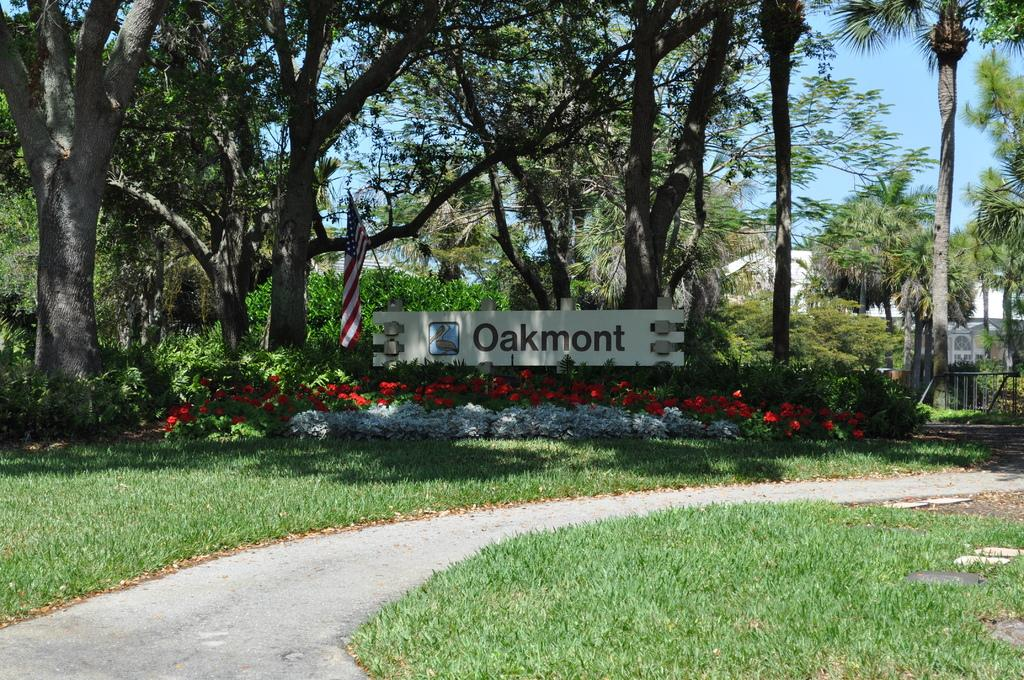What type of surface can be seen in the image? There is ground visible in the image. What type of pathway is present in the image? There is a road in the image. What type of vegetation is present in the image? There is grass, plants, and trees in the image. What type of signage is present in the image? There are posters and a flag in the image. What type of objects are on the ground in the image? There are objects on the ground in the image. What type of structure is present in the image? There is a wall in the image. What type of sky is visible in the image? The sky is visible in the image. What type of bell can be heard ringing in the image? There is no bell present in the image, and therefore no sound can be heard. What type of shade is covering the plants in the image? There is no shade covering the plants in the image; they are exposed to the sky. What type of knot is tied around the flagpole in the image? There is no knot tied around the flagpole in the image; the flag is simply attached to the pole. 